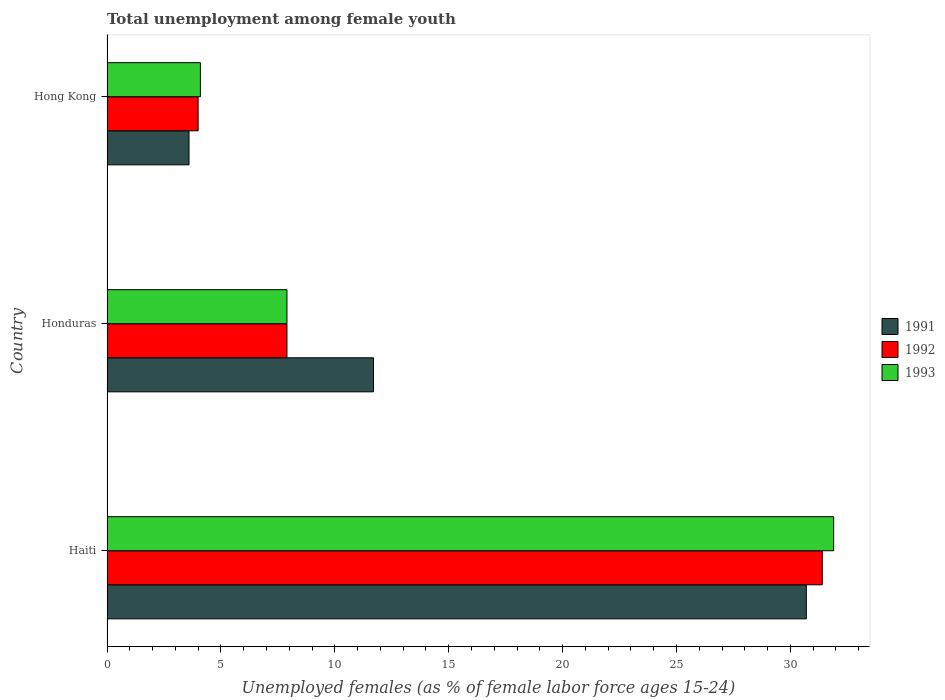Are the number of bars on each tick of the Y-axis equal?
Give a very brief answer. Yes. How many bars are there on the 1st tick from the bottom?
Offer a terse response. 3. What is the label of the 1st group of bars from the top?
Give a very brief answer. Hong Kong. What is the percentage of unemployed females in in 1991 in Honduras?
Give a very brief answer. 11.7. Across all countries, what is the maximum percentage of unemployed females in in 1993?
Your answer should be very brief. 31.9. Across all countries, what is the minimum percentage of unemployed females in in 1993?
Your answer should be compact. 4.1. In which country was the percentage of unemployed females in in 1992 maximum?
Provide a succinct answer. Haiti. In which country was the percentage of unemployed females in in 1992 minimum?
Give a very brief answer. Hong Kong. What is the total percentage of unemployed females in in 1991 in the graph?
Your response must be concise. 46. What is the difference between the percentage of unemployed females in in 1993 in Honduras and that in Hong Kong?
Provide a succinct answer. 3.8. What is the difference between the percentage of unemployed females in in 1991 in Honduras and the percentage of unemployed females in in 1993 in Haiti?
Make the answer very short. -20.2. What is the average percentage of unemployed females in in 1992 per country?
Keep it short and to the point. 14.43. What is the difference between the percentage of unemployed females in in 1992 and percentage of unemployed females in in 1991 in Hong Kong?
Your answer should be compact. 0.4. What is the ratio of the percentage of unemployed females in in 1992 in Haiti to that in Hong Kong?
Ensure brevity in your answer.  7.85. Is the percentage of unemployed females in in 1992 in Haiti less than that in Hong Kong?
Your answer should be very brief. No. Is the difference between the percentage of unemployed females in in 1992 in Haiti and Honduras greater than the difference between the percentage of unemployed females in in 1991 in Haiti and Honduras?
Provide a succinct answer. Yes. What is the difference between the highest and the second highest percentage of unemployed females in in 1993?
Ensure brevity in your answer.  24. What is the difference between the highest and the lowest percentage of unemployed females in in 1993?
Keep it short and to the point. 27.8. Is the sum of the percentage of unemployed females in in 1991 in Haiti and Honduras greater than the maximum percentage of unemployed females in in 1993 across all countries?
Offer a terse response. Yes. How many bars are there?
Your answer should be compact. 9. What is the difference between two consecutive major ticks on the X-axis?
Your answer should be very brief. 5. Are the values on the major ticks of X-axis written in scientific E-notation?
Provide a succinct answer. No. Where does the legend appear in the graph?
Provide a short and direct response. Center right. What is the title of the graph?
Give a very brief answer. Total unemployment among female youth. What is the label or title of the X-axis?
Ensure brevity in your answer.  Unemployed females (as % of female labor force ages 15-24). What is the label or title of the Y-axis?
Offer a very short reply. Country. What is the Unemployed females (as % of female labor force ages 15-24) of 1991 in Haiti?
Offer a very short reply. 30.7. What is the Unemployed females (as % of female labor force ages 15-24) of 1992 in Haiti?
Your answer should be very brief. 31.4. What is the Unemployed females (as % of female labor force ages 15-24) of 1993 in Haiti?
Provide a succinct answer. 31.9. What is the Unemployed females (as % of female labor force ages 15-24) in 1991 in Honduras?
Your answer should be compact. 11.7. What is the Unemployed females (as % of female labor force ages 15-24) of 1992 in Honduras?
Offer a terse response. 7.9. What is the Unemployed females (as % of female labor force ages 15-24) of 1993 in Honduras?
Give a very brief answer. 7.9. What is the Unemployed females (as % of female labor force ages 15-24) of 1991 in Hong Kong?
Keep it short and to the point. 3.6. What is the Unemployed females (as % of female labor force ages 15-24) of 1992 in Hong Kong?
Provide a succinct answer. 4. What is the Unemployed females (as % of female labor force ages 15-24) in 1993 in Hong Kong?
Your response must be concise. 4.1. Across all countries, what is the maximum Unemployed females (as % of female labor force ages 15-24) of 1991?
Keep it short and to the point. 30.7. Across all countries, what is the maximum Unemployed females (as % of female labor force ages 15-24) of 1992?
Provide a short and direct response. 31.4. Across all countries, what is the maximum Unemployed females (as % of female labor force ages 15-24) of 1993?
Your response must be concise. 31.9. Across all countries, what is the minimum Unemployed females (as % of female labor force ages 15-24) of 1991?
Your response must be concise. 3.6. Across all countries, what is the minimum Unemployed females (as % of female labor force ages 15-24) of 1993?
Offer a very short reply. 4.1. What is the total Unemployed females (as % of female labor force ages 15-24) in 1992 in the graph?
Provide a succinct answer. 43.3. What is the total Unemployed females (as % of female labor force ages 15-24) of 1993 in the graph?
Ensure brevity in your answer.  43.9. What is the difference between the Unemployed females (as % of female labor force ages 15-24) in 1991 in Haiti and that in Hong Kong?
Offer a very short reply. 27.1. What is the difference between the Unemployed females (as % of female labor force ages 15-24) in 1992 in Haiti and that in Hong Kong?
Give a very brief answer. 27.4. What is the difference between the Unemployed females (as % of female labor force ages 15-24) in 1993 in Haiti and that in Hong Kong?
Keep it short and to the point. 27.8. What is the difference between the Unemployed females (as % of female labor force ages 15-24) in 1991 in Honduras and that in Hong Kong?
Give a very brief answer. 8.1. What is the difference between the Unemployed females (as % of female labor force ages 15-24) of 1992 in Honduras and that in Hong Kong?
Provide a succinct answer. 3.9. What is the difference between the Unemployed females (as % of female labor force ages 15-24) in 1991 in Haiti and the Unemployed females (as % of female labor force ages 15-24) in 1992 in Honduras?
Offer a very short reply. 22.8. What is the difference between the Unemployed females (as % of female labor force ages 15-24) in 1991 in Haiti and the Unemployed females (as % of female labor force ages 15-24) in 1993 in Honduras?
Your response must be concise. 22.8. What is the difference between the Unemployed females (as % of female labor force ages 15-24) of 1991 in Haiti and the Unemployed females (as % of female labor force ages 15-24) of 1992 in Hong Kong?
Your answer should be compact. 26.7. What is the difference between the Unemployed females (as % of female labor force ages 15-24) in 1991 in Haiti and the Unemployed females (as % of female labor force ages 15-24) in 1993 in Hong Kong?
Offer a very short reply. 26.6. What is the difference between the Unemployed females (as % of female labor force ages 15-24) in 1992 in Haiti and the Unemployed females (as % of female labor force ages 15-24) in 1993 in Hong Kong?
Provide a succinct answer. 27.3. What is the difference between the Unemployed females (as % of female labor force ages 15-24) of 1991 in Honduras and the Unemployed females (as % of female labor force ages 15-24) of 1992 in Hong Kong?
Give a very brief answer. 7.7. What is the difference between the Unemployed females (as % of female labor force ages 15-24) of 1991 in Honduras and the Unemployed females (as % of female labor force ages 15-24) of 1993 in Hong Kong?
Your response must be concise. 7.6. What is the difference between the Unemployed females (as % of female labor force ages 15-24) of 1992 in Honduras and the Unemployed females (as % of female labor force ages 15-24) of 1993 in Hong Kong?
Offer a terse response. 3.8. What is the average Unemployed females (as % of female labor force ages 15-24) of 1991 per country?
Ensure brevity in your answer.  15.33. What is the average Unemployed females (as % of female labor force ages 15-24) in 1992 per country?
Your answer should be very brief. 14.43. What is the average Unemployed females (as % of female labor force ages 15-24) of 1993 per country?
Provide a succinct answer. 14.63. What is the difference between the Unemployed females (as % of female labor force ages 15-24) in 1992 and Unemployed females (as % of female labor force ages 15-24) in 1993 in Haiti?
Provide a short and direct response. -0.5. What is the difference between the Unemployed females (as % of female labor force ages 15-24) of 1991 and Unemployed females (as % of female labor force ages 15-24) of 1993 in Honduras?
Offer a very short reply. 3.8. What is the difference between the Unemployed females (as % of female labor force ages 15-24) of 1992 and Unemployed females (as % of female labor force ages 15-24) of 1993 in Honduras?
Your answer should be very brief. 0. What is the difference between the Unemployed females (as % of female labor force ages 15-24) in 1991 and Unemployed females (as % of female labor force ages 15-24) in 1992 in Hong Kong?
Make the answer very short. -0.4. What is the difference between the Unemployed females (as % of female labor force ages 15-24) in 1991 and Unemployed females (as % of female labor force ages 15-24) in 1993 in Hong Kong?
Give a very brief answer. -0.5. What is the ratio of the Unemployed females (as % of female labor force ages 15-24) in 1991 in Haiti to that in Honduras?
Make the answer very short. 2.62. What is the ratio of the Unemployed females (as % of female labor force ages 15-24) of 1992 in Haiti to that in Honduras?
Provide a short and direct response. 3.97. What is the ratio of the Unemployed females (as % of female labor force ages 15-24) of 1993 in Haiti to that in Honduras?
Your response must be concise. 4.04. What is the ratio of the Unemployed females (as % of female labor force ages 15-24) of 1991 in Haiti to that in Hong Kong?
Keep it short and to the point. 8.53. What is the ratio of the Unemployed females (as % of female labor force ages 15-24) in 1992 in Haiti to that in Hong Kong?
Your answer should be very brief. 7.85. What is the ratio of the Unemployed females (as % of female labor force ages 15-24) of 1993 in Haiti to that in Hong Kong?
Give a very brief answer. 7.78. What is the ratio of the Unemployed females (as % of female labor force ages 15-24) in 1992 in Honduras to that in Hong Kong?
Your answer should be compact. 1.98. What is the ratio of the Unemployed females (as % of female labor force ages 15-24) in 1993 in Honduras to that in Hong Kong?
Give a very brief answer. 1.93. What is the difference between the highest and the second highest Unemployed females (as % of female labor force ages 15-24) of 1991?
Give a very brief answer. 19. What is the difference between the highest and the second highest Unemployed females (as % of female labor force ages 15-24) in 1993?
Your answer should be very brief. 24. What is the difference between the highest and the lowest Unemployed females (as % of female labor force ages 15-24) of 1991?
Offer a terse response. 27.1. What is the difference between the highest and the lowest Unemployed females (as % of female labor force ages 15-24) of 1992?
Offer a very short reply. 27.4. What is the difference between the highest and the lowest Unemployed females (as % of female labor force ages 15-24) in 1993?
Offer a very short reply. 27.8. 